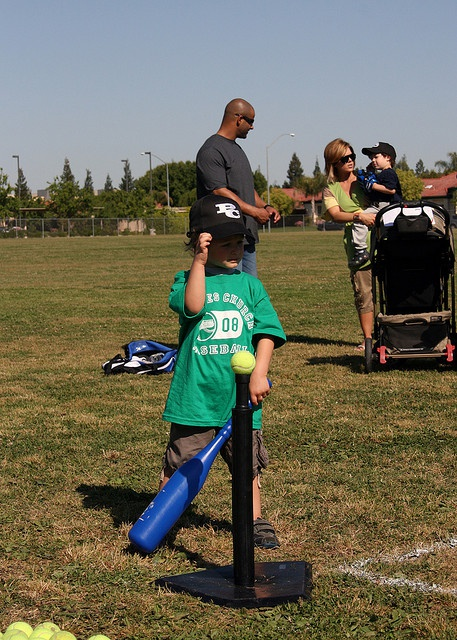Describe the objects in this image and their specific colors. I can see people in darkgray, black, teal, and turquoise tones, people in darkgray, black, gray, and tan tones, people in darkgray, black, maroon, and brown tones, baseball bat in darkgray, blue, navy, and darkblue tones, and people in darkgray, black, tan, and lightgray tones in this image. 